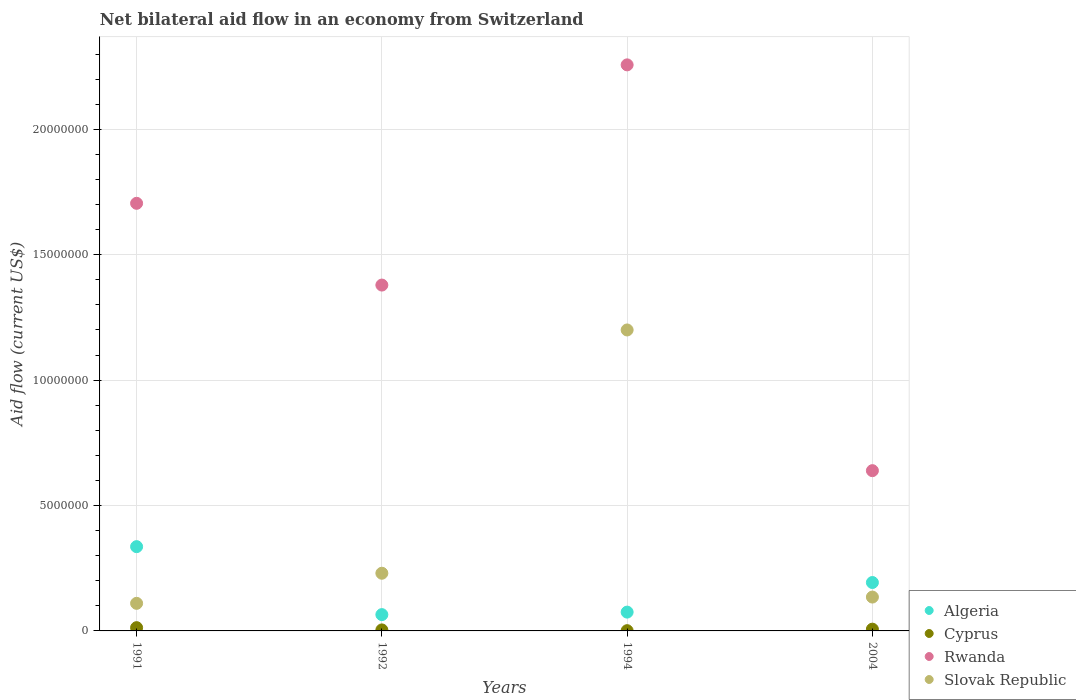How many different coloured dotlines are there?
Ensure brevity in your answer.  4. Is the number of dotlines equal to the number of legend labels?
Provide a short and direct response. Yes. What is the net bilateral aid flow in Rwanda in 1991?
Make the answer very short. 1.70e+07. Across all years, what is the maximum net bilateral aid flow in Algeria?
Provide a short and direct response. 3.36e+06. Across all years, what is the minimum net bilateral aid flow in Rwanda?
Ensure brevity in your answer.  6.39e+06. In which year was the net bilateral aid flow in Cyprus maximum?
Ensure brevity in your answer.  1991. In which year was the net bilateral aid flow in Cyprus minimum?
Give a very brief answer. 1994. What is the total net bilateral aid flow in Rwanda in the graph?
Keep it short and to the point. 5.98e+07. What is the difference between the net bilateral aid flow in Cyprus in 1994 and that in 2004?
Your answer should be compact. -6.00e+04. What is the difference between the net bilateral aid flow in Algeria in 2004 and the net bilateral aid flow in Cyprus in 1992?
Provide a succinct answer. 1.89e+06. What is the average net bilateral aid flow in Slovak Republic per year?
Give a very brief answer. 4.19e+06. In the year 1994, what is the difference between the net bilateral aid flow in Algeria and net bilateral aid flow in Slovak Republic?
Offer a terse response. -1.12e+07. In how many years, is the net bilateral aid flow in Algeria greater than 6000000 US$?
Ensure brevity in your answer.  0. What is the ratio of the net bilateral aid flow in Cyprus in 1992 to that in 2004?
Your response must be concise. 0.57. Is the net bilateral aid flow in Rwanda in 1991 less than that in 1992?
Offer a very short reply. No. What is the difference between the highest and the lowest net bilateral aid flow in Rwanda?
Your answer should be very brief. 1.62e+07. Is the net bilateral aid flow in Cyprus strictly greater than the net bilateral aid flow in Algeria over the years?
Give a very brief answer. No. How many dotlines are there?
Make the answer very short. 4. How many years are there in the graph?
Give a very brief answer. 4. Does the graph contain any zero values?
Your answer should be very brief. No. Where does the legend appear in the graph?
Your response must be concise. Bottom right. How many legend labels are there?
Your answer should be very brief. 4. How are the legend labels stacked?
Give a very brief answer. Vertical. What is the title of the graph?
Give a very brief answer. Net bilateral aid flow in an economy from Switzerland. Does "East Asia (developing only)" appear as one of the legend labels in the graph?
Offer a terse response. No. What is the Aid flow (current US$) in Algeria in 1991?
Offer a very short reply. 3.36e+06. What is the Aid flow (current US$) of Rwanda in 1991?
Give a very brief answer. 1.70e+07. What is the Aid flow (current US$) of Slovak Republic in 1991?
Offer a very short reply. 1.10e+06. What is the Aid flow (current US$) in Algeria in 1992?
Ensure brevity in your answer.  6.50e+05. What is the Aid flow (current US$) of Rwanda in 1992?
Keep it short and to the point. 1.38e+07. What is the Aid flow (current US$) in Slovak Republic in 1992?
Offer a terse response. 2.30e+06. What is the Aid flow (current US$) of Algeria in 1994?
Give a very brief answer. 7.50e+05. What is the Aid flow (current US$) in Cyprus in 1994?
Make the answer very short. 10000. What is the Aid flow (current US$) in Rwanda in 1994?
Give a very brief answer. 2.26e+07. What is the Aid flow (current US$) of Slovak Republic in 1994?
Your answer should be very brief. 1.20e+07. What is the Aid flow (current US$) in Algeria in 2004?
Provide a short and direct response. 1.93e+06. What is the Aid flow (current US$) in Rwanda in 2004?
Make the answer very short. 6.39e+06. What is the Aid flow (current US$) in Slovak Republic in 2004?
Provide a short and direct response. 1.35e+06. Across all years, what is the maximum Aid flow (current US$) in Algeria?
Ensure brevity in your answer.  3.36e+06. Across all years, what is the maximum Aid flow (current US$) of Rwanda?
Your answer should be compact. 2.26e+07. Across all years, what is the maximum Aid flow (current US$) in Slovak Republic?
Offer a terse response. 1.20e+07. Across all years, what is the minimum Aid flow (current US$) in Algeria?
Provide a short and direct response. 6.50e+05. Across all years, what is the minimum Aid flow (current US$) of Cyprus?
Make the answer very short. 10000. Across all years, what is the minimum Aid flow (current US$) in Rwanda?
Your response must be concise. 6.39e+06. Across all years, what is the minimum Aid flow (current US$) in Slovak Republic?
Your answer should be very brief. 1.10e+06. What is the total Aid flow (current US$) of Algeria in the graph?
Keep it short and to the point. 6.69e+06. What is the total Aid flow (current US$) of Cyprus in the graph?
Ensure brevity in your answer.  2.50e+05. What is the total Aid flow (current US$) in Rwanda in the graph?
Give a very brief answer. 5.98e+07. What is the total Aid flow (current US$) in Slovak Republic in the graph?
Ensure brevity in your answer.  1.68e+07. What is the difference between the Aid flow (current US$) of Algeria in 1991 and that in 1992?
Provide a succinct answer. 2.71e+06. What is the difference between the Aid flow (current US$) in Rwanda in 1991 and that in 1992?
Give a very brief answer. 3.26e+06. What is the difference between the Aid flow (current US$) in Slovak Republic in 1991 and that in 1992?
Offer a very short reply. -1.20e+06. What is the difference between the Aid flow (current US$) of Algeria in 1991 and that in 1994?
Give a very brief answer. 2.61e+06. What is the difference between the Aid flow (current US$) of Rwanda in 1991 and that in 1994?
Provide a succinct answer. -5.52e+06. What is the difference between the Aid flow (current US$) in Slovak Republic in 1991 and that in 1994?
Provide a succinct answer. -1.09e+07. What is the difference between the Aid flow (current US$) of Algeria in 1991 and that in 2004?
Provide a succinct answer. 1.43e+06. What is the difference between the Aid flow (current US$) in Cyprus in 1991 and that in 2004?
Make the answer very short. 6.00e+04. What is the difference between the Aid flow (current US$) of Rwanda in 1991 and that in 2004?
Provide a short and direct response. 1.07e+07. What is the difference between the Aid flow (current US$) of Slovak Republic in 1991 and that in 2004?
Keep it short and to the point. -2.50e+05. What is the difference between the Aid flow (current US$) in Cyprus in 1992 and that in 1994?
Offer a terse response. 3.00e+04. What is the difference between the Aid flow (current US$) in Rwanda in 1992 and that in 1994?
Provide a short and direct response. -8.78e+06. What is the difference between the Aid flow (current US$) in Slovak Republic in 1992 and that in 1994?
Your answer should be very brief. -9.70e+06. What is the difference between the Aid flow (current US$) of Algeria in 1992 and that in 2004?
Your response must be concise. -1.28e+06. What is the difference between the Aid flow (current US$) in Rwanda in 1992 and that in 2004?
Your answer should be very brief. 7.40e+06. What is the difference between the Aid flow (current US$) in Slovak Republic in 1992 and that in 2004?
Your answer should be compact. 9.50e+05. What is the difference between the Aid flow (current US$) in Algeria in 1994 and that in 2004?
Keep it short and to the point. -1.18e+06. What is the difference between the Aid flow (current US$) in Cyprus in 1994 and that in 2004?
Your answer should be compact. -6.00e+04. What is the difference between the Aid flow (current US$) in Rwanda in 1994 and that in 2004?
Offer a very short reply. 1.62e+07. What is the difference between the Aid flow (current US$) of Slovak Republic in 1994 and that in 2004?
Your response must be concise. 1.06e+07. What is the difference between the Aid flow (current US$) of Algeria in 1991 and the Aid flow (current US$) of Cyprus in 1992?
Your answer should be very brief. 3.32e+06. What is the difference between the Aid flow (current US$) of Algeria in 1991 and the Aid flow (current US$) of Rwanda in 1992?
Your answer should be compact. -1.04e+07. What is the difference between the Aid flow (current US$) of Algeria in 1991 and the Aid flow (current US$) of Slovak Republic in 1992?
Provide a succinct answer. 1.06e+06. What is the difference between the Aid flow (current US$) of Cyprus in 1991 and the Aid flow (current US$) of Rwanda in 1992?
Your answer should be compact. -1.37e+07. What is the difference between the Aid flow (current US$) in Cyprus in 1991 and the Aid flow (current US$) in Slovak Republic in 1992?
Give a very brief answer. -2.17e+06. What is the difference between the Aid flow (current US$) in Rwanda in 1991 and the Aid flow (current US$) in Slovak Republic in 1992?
Provide a short and direct response. 1.48e+07. What is the difference between the Aid flow (current US$) of Algeria in 1991 and the Aid flow (current US$) of Cyprus in 1994?
Ensure brevity in your answer.  3.35e+06. What is the difference between the Aid flow (current US$) in Algeria in 1991 and the Aid flow (current US$) in Rwanda in 1994?
Your answer should be compact. -1.92e+07. What is the difference between the Aid flow (current US$) in Algeria in 1991 and the Aid flow (current US$) in Slovak Republic in 1994?
Make the answer very short. -8.64e+06. What is the difference between the Aid flow (current US$) in Cyprus in 1991 and the Aid flow (current US$) in Rwanda in 1994?
Give a very brief answer. -2.24e+07. What is the difference between the Aid flow (current US$) of Cyprus in 1991 and the Aid flow (current US$) of Slovak Republic in 1994?
Provide a succinct answer. -1.19e+07. What is the difference between the Aid flow (current US$) in Rwanda in 1991 and the Aid flow (current US$) in Slovak Republic in 1994?
Give a very brief answer. 5.05e+06. What is the difference between the Aid flow (current US$) in Algeria in 1991 and the Aid flow (current US$) in Cyprus in 2004?
Your answer should be compact. 3.29e+06. What is the difference between the Aid flow (current US$) in Algeria in 1991 and the Aid flow (current US$) in Rwanda in 2004?
Your answer should be very brief. -3.03e+06. What is the difference between the Aid flow (current US$) of Algeria in 1991 and the Aid flow (current US$) of Slovak Republic in 2004?
Provide a short and direct response. 2.01e+06. What is the difference between the Aid flow (current US$) in Cyprus in 1991 and the Aid flow (current US$) in Rwanda in 2004?
Keep it short and to the point. -6.26e+06. What is the difference between the Aid flow (current US$) in Cyprus in 1991 and the Aid flow (current US$) in Slovak Republic in 2004?
Give a very brief answer. -1.22e+06. What is the difference between the Aid flow (current US$) in Rwanda in 1991 and the Aid flow (current US$) in Slovak Republic in 2004?
Make the answer very short. 1.57e+07. What is the difference between the Aid flow (current US$) in Algeria in 1992 and the Aid flow (current US$) in Cyprus in 1994?
Your answer should be compact. 6.40e+05. What is the difference between the Aid flow (current US$) of Algeria in 1992 and the Aid flow (current US$) of Rwanda in 1994?
Your answer should be compact. -2.19e+07. What is the difference between the Aid flow (current US$) of Algeria in 1992 and the Aid flow (current US$) of Slovak Republic in 1994?
Provide a short and direct response. -1.14e+07. What is the difference between the Aid flow (current US$) of Cyprus in 1992 and the Aid flow (current US$) of Rwanda in 1994?
Make the answer very short. -2.25e+07. What is the difference between the Aid flow (current US$) in Cyprus in 1992 and the Aid flow (current US$) in Slovak Republic in 1994?
Keep it short and to the point. -1.20e+07. What is the difference between the Aid flow (current US$) of Rwanda in 1992 and the Aid flow (current US$) of Slovak Republic in 1994?
Your answer should be very brief. 1.79e+06. What is the difference between the Aid flow (current US$) of Algeria in 1992 and the Aid flow (current US$) of Cyprus in 2004?
Offer a very short reply. 5.80e+05. What is the difference between the Aid flow (current US$) of Algeria in 1992 and the Aid flow (current US$) of Rwanda in 2004?
Your answer should be very brief. -5.74e+06. What is the difference between the Aid flow (current US$) of Algeria in 1992 and the Aid flow (current US$) of Slovak Republic in 2004?
Your response must be concise. -7.00e+05. What is the difference between the Aid flow (current US$) of Cyprus in 1992 and the Aid flow (current US$) of Rwanda in 2004?
Make the answer very short. -6.35e+06. What is the difference between the Aid flow (current US$) in Cyprus in 1992 and the Aid flow (current US$) in Slovak Republic in 2004?
Offer a very short reply. -1.31e+06. What is the difference between the Aid flow (current US$) in Rwanda in 1992 and the Aid flow (current US$) in Slovak Republic in 2004?
Make the answer very short. 1.24e+07. What is the difference between the Aid flow (current US$) of Algeria in 1994 and the Aid flow (current US$) of Cyprus in 2004?
Your response must be concise. 6.80e+05. What is the difference between the Aid flow (current US$) in Algeria in 1994 and the Aid flow (current US$) in Rwanda in 2004?
Your answer should be compact. -5.64e+06. What is the difference between the Aid flow (current US$) of Algeria in 1994 and the Aid flow (current US$) of Slovak Republic in 2004?
Make the answer very short. -6.00e+05. What is the difference between the Aid flow (current US$) in Cyprus in 1994 and the Aid flow (current US$) in Rwanda in 2004?
Keep it short and to the point. -6.38e+06. What is the difference between the Aid flow (current US$) in Cyprus in 1994 and the Aid flow (current US$) in Slovak Republic in 2004?
Your answer should be compact. -1.34e+06. What is the difference between the Aid flow (current US$) of Rwanda in 1994 and the Aid flow (current US$) of Slovak Republic in 2004?
Ensure brevity in your answer.  2.12e+07. What is the average Aid flow (current US$) of Algeria per year?
Ensure brevity in your answer.  1.67e+06. What is the average Aid flow (current US$) of Cyprus per year?
Give a very brief answer. 6.25e+04. What is the average Aid flow (current US$) of Rwanda per year?
Provide a short and direct response. 1.50e+07. What is the average Aid flow (current US$) of Slovak Republic per year?
Your response must be concise. 4.19e+06. In the year 1991, what is the difference between the Aid flow (current US$) in Algeria and Aid flow (current US$) in Cyprus?
Your answer should be very brief. 3.23e+06. In the year 1991, what is the difference between the Aid flow (current US$) in Algeria and Aid flow (current US$) in Rwanda?
Provide a succinct answer. -1.37e+07. In the year 1991, what is the difference between the Aid flow (current US$) in Algeria and Aid flow (current US$) in Slovak Republic?
Offer a very short reply. 2.26e+06. In the year 1991, what is the difference between the Aid flow (current US$) of Cyprus and Aid flow (current US$) of Rwanda?
Give a very brief answer. -1.69e+07. In the year 1991, what is the difference between the Aid flow (current US$) in Cyprus and Aid flow (current US$) in Slovak Republic?
Offer a terse response. -9.70e+05. In the year 1991, what is the difference between the Aid flow (current US$) in Rwanda and Aid flow (current US$) in Slovak Republic?
Make the answer very short. 1.60e+07. In the year 1992, what is the difference between the Aid flow (current US$) of Algeria and Aid flow (current US$) of Rwanda?
Give a very brief answer. -1.31e+07. In the year 1992, what is the difference between the Aid flow (current US$) in Algeria and Aid flow (current US$) in Slovak Republic?
Your response must be concise. -1.65e+06. In the year 1992, what is the difference between the Aid flow (current US$) in Cyprus and Aid flow (current US$) in Rwanda?
Give a very brief answer. -1.38e+07. In the year 1992, what is the difference between the Aid flow (current US$) of Cyprus and Aid flow (current US$) of Slovak Republic?
Make the answer very short. -2.26e+06. In the year 1992, what is the difference between the Aid flow (current US$) of Rwanda and Aid flow (current US$) of Slovak Republic?
Offer a terse response. 1.15e+07. In the year 1994, what is the difference between the Aid flow (current US$) of Algeria and Aid flow (current US$) of Cyprus?
Offer a very short reply. 7.40e+05. In the year 1994, what is the difference between the Aid flow (current US$) of Algeria and Aid flow (current US$) of Rwanda?
Make the answer very short. -2.18e+07. In the year 1994, what is the difference between the Aid flow (current US$) in Algeria and Aid flow (current US$) in Slovak Republic?
Give a very brief answer. -1.12e+07. In the year 1994, what is the difference between the Aid flow (current US$) of Cyprus and Aid flow (current US$) of Rwanda?
Your answer should be compact. -2.26e+07. In the year 1994, what is the difference between the Aid flow (current US$) of Cyprus and Aid flow (current US$) of Slovak Republic?
Ensure brevity in your answer.  -1.20e+07. In the year 1994, what is the difference between the Aid flow (current US$) in Rwanda and Aid flow (current US$) in Slovak Republic?
Give a very brief answer. 1.06e+07. In the year 2004, what is the difference between the Aid flow (current US$) in Algeria and Aid flow (current US$) in Cyprus?
Your answer should be very brief. 1.86e+06. In the year 2004, what is the difference between the Aid flow (current US$) of Algeria and Aid flow (current US$) of Rwanda?
Ensure brevity in your answer.  -4.46e+06. In the year 2004, what is the difference between the Aid flow (current US$) in Algeria and Aid flow (current US$) in Slovak Republic?
Make the answer very short. 5.80e+05. In the year 2004, what is the difference between the Aid flow (current US$) of Cyprus and Aid flow (current US$) of Rwanda?
Your answer should be compact. -6.32e+06. In the year 2004, what is the difference between the Aid flow (current US$) in Cyprus and Aid flow (current US$) in Slovak Republic?
Ensure brevity in your answer.  -1.28e+06. In the year 2004, what is the difference between the Aid flow (current US$) of Rwanda and Aid flow (current US$) of Slovak Republic?
Provide a succinct answer. 5.04e+06. What is the ratio of the Aid flow (current US$) of Algeria in 1991 to that in 1992?
Your answer should be compact. 5.17. What is the ratio of the Aid flow (current US$) in Rwanda in 1991 to that in 1992?
Provide a succinct answer. 1.24. What is the ratio of the Aid flow (current US$) in Slovak Republic in 1991 to that in 1992?
Keep it short and to the point. 0.48. What is the ratio of the Aid flow (current US$) of Algeria in 1991 to that in 1994?
Your response must be concise. 4.48. What is the ratio of the Aid flow (current US$) in Cyprus in 1991 to that in 1994?
Give a very brief answer. 13. What is the ratio of the Aid flow (current US$) in Rwanda in 1991 to that in 1994?
Offer a very short reply. 0.76. What is the ratio of the Aid flow (current US$) of Slovak Republic in 1991 to that in 1994?
Make the answer very short. 0.09. What is the ratio of the Aid flow (current US$) in Algeria in 1991 to that in 2004?
Your answer should be very brief. 1.74. What is the ratio of the Aid flow (current US$) of Cyprus in 1991 to that in 2004?
Keep it short and to the point. 1.86. What is the ratio of the Aid flow (current US$) in Rwanda in 1991 to that in 2004?
Offer a very short reply. 2.67. What is the ratio of the Aid flow (current US$) in Slovak Republic in 1991 to that in 2004?
Ensure brevity in your answer.  0.81. What is the ratio of the Aid flow (current US$) in Algeria in 1992 to that in 1994?
Your answer should be compact. 0.87. What is the ratio of the Aid flow (current US$) in Rwanda in 1992 to that in 1994?
Keep it short and to the point. 0.61. What is the ratio of the Aid flow (current US$) in Slovak Republic in 1992 to that in 1994?
Your answer should be very brief. 0.19. What is the ratio of the Aid flow (current US$) of Algeria in 1992 to that in 2004?
Your answer should be compact. 0.34. What is the ratio of the Aid flow (current US$) in Cyprus in 1992 to that in 2004?
Keep it short and to the point. 0.57. What is the ratio of the Aid flow (current US$) in Rwanda in 1992 to that in 2004?
Provide a short and direct response. 2.16. What is the ratio of the Aid flow (current US$) in Slovak Republic in 1992 to that in 2004?
Provide a short and direct response. 1.7. What is the ratio of the Aid flow (current US$) in Algeria in 1994 to that in 2004?
Provide a short and direct response. 0.39. What is the ratio of the Aid flow (current US$) in Cyprus in 1994 to that in 2004?
Keep it short and to the point. 0.14. What is the ratio of the Aid flow (current US$) of Rwanda in 1994 to that in 2004?
Your answer should be very brief. 3.53. What is the ratio of the Aid flow (current US$) in Slovak Republic in 1994 to that in 2004?
Make the answer very short. 8.89. What is the difference between the highest and the second highest Aid flow (current US$) of Algeria?
Make the answer very short. 1.43e+06. What is the difference between the highest and the second highest Aid flow (current US$) of Rwanda?
Offer a very short reply. 5.52e+06. What is the difference between the highest and the second highest Aid flow (current US$) in Slovak Republic?
Your answer should be very brief. 9.70e+06. What is the difference between the highest and the lowest Aid flow (current US$) in Algeria?
Provide a short and direct response. 2.71e+06. What is the difference between the highest and the lowest Aid flow (current US$) in Cyprus?
Offer a terse response. 1.20e+05. What is the difference between the highest and the lowest Aid flow (current US$) of Rwanda?
Offer a very short reply. 1.62e+07. What is the difference between the highest and the lowest Aid flow (current US$) in Slovak Republic?
Offer a very short reply. 1.09e+07. 